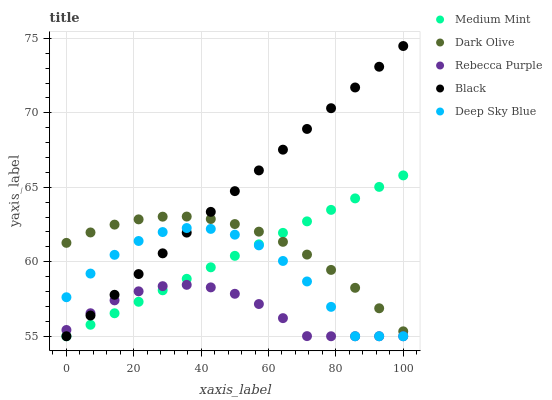Does Rebecca Purple have the minimum area under the curve?
Answer yes or no. Yes. Does Black have the maximum area under the curve?
Answer yes or no. Yes. Does Dark Olive have the minimum area under the curve?
Answer yes or no. No. Does Dark Olive have the maximum area under the curve?
Answer yes or no. No. Is Medium Mint the smoothest?
Answer yes or no. Yes. Is Deep Sky Blue the roughest?
Answer yes or no. Yes. Is Dark Olive the smoothest?
Answer yes or no. No. Is Dark Olive the roughest?
Answer yes or no. No. Does Medium Mint have the lowest value?
Answer yes or no. Yes. Does Dark Olive have the lowest value?
Answer yes or no. No. Does Black have the highest value?
Answer yes or no. Yes. Does Dark Olive have the highest value?
Answer yes or no. No. Is Deep Sky Blue less than Dark Olive?
Answer yes or no. Yes. Is Dark Olive greater than Deep Sky Blue?
Answer yes or no. Yes. Does Medium Mint intersect Dark Olive?
Answer yes or no. Yes. Is Medium Mint less than Dark Olive?
Answer yes or no. No. Is Medium Mint greater than Dark Olive?
Answer yes or no. No. Does Deep Sky Blue intersect Dark Olive?
Answer yes or no. No. 